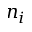<formula> <loc_0><loc_0><loc_500><loc_500>n _ { i }</formula> 